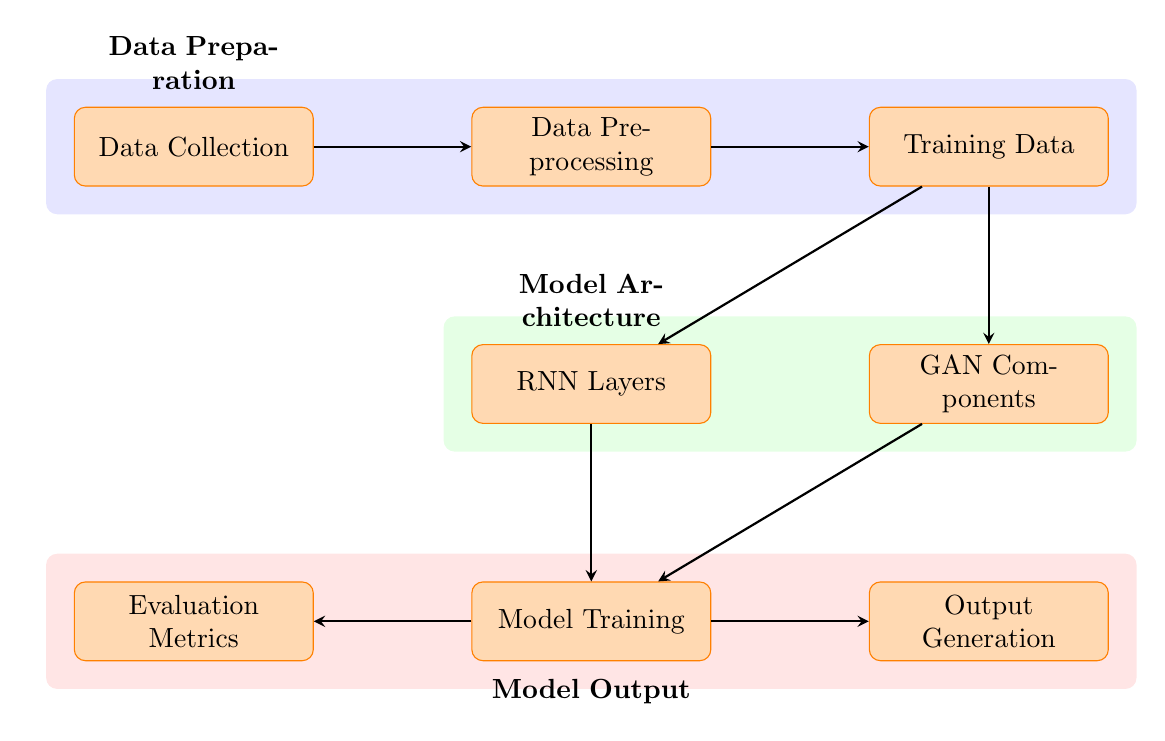What is the first step in the process? The first step is the "Data Collection" node, which is positioned at the far left of the diagram.
Answer: Data Collection How many nodes are there in the diagram? Counting all the process nodes from the left to the right, there are eight nodes in total in the diagram.
Answer: Eight What is the relationship between "Data Preprocessing" and "Training Data"? "Data Preprocessing" is the direct predecessor of "Training Data", indicated by the arrow going from "Data Preprocessing" to "Training Data".
Answer: Direct predecessor What are the two components that lead to "Model Training"? Both "RNN Layers" and "GAN Components" lead to "Model Training", as indicated by the arrows pointing to it from both nodes.
Answer: RNN Layers, GAN Components What does the background color of the "Model Architecture" section represent? The background color green in the "Model Architecture" section highlights the cluster of components related to the architecture of the model being used.
Answer: Model Architecture What is evaluated after the "Model Training" process? "Evaluation Metrics" is evaluated after the "Model Training" process. This can be observed as there's an arrow leading from "Model Training" to "Evaluation Metrics".
Answer: Evaluation Metrics Which process is responsible for preparing the "Training Data"? "Data Preprocessing" is responsible for preparing the "Training Data", as it follows the "Data Collection" step and leads to the "Training Data".
Answer: Data Preprocessing What type of model architecture is indicated in the diagram? The diagram indicates a model architecture involving "RNN Layers" and "GAN Components", showcasing the use of generative models.
Answer: RNN Layers and GAN Components 